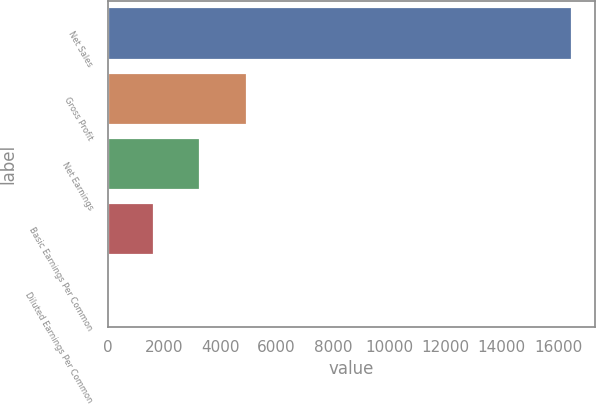Convert chart to OTSL. <chart><loc_0><loc_0><loc_500><loc_500><bar_chart><fcel>Net Sales<fcel>Gross Profit<fcel>Net Earnings<fcel>Basic Earnings Per Common<fcel>Diluted Earnings Per Common<nl><fcel>16496<fcel>4949.32<fcel>3299.79<fcel>1650.26<fcel>0.73<nl></chart> 